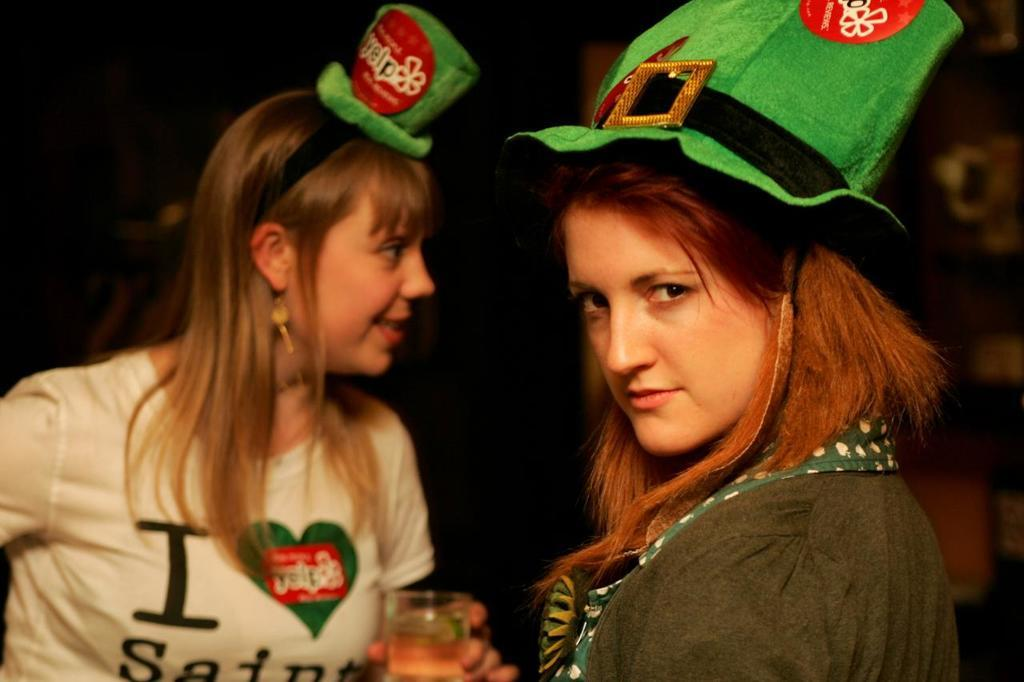How many women are in the image? There are two women in the image. What are the women doing in the image? The women are standing in the image. What are the women wearing on their heads? The women are wearing hats in the image. What object can be seen in the image besides the women? There is a glass in the image. What type of fly is buzzing around the women's hats in the image? There are no flies present in the image; the women are wearing hats, but no insects are visible. 